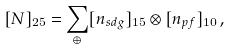Convert formula to latex. <formula><loc_0><loc_0><loc_500><loc_500>[ N ] _ { 2 5 } = \sum _ { \oplus } [ n _ { s d g } ] _ { 1 5 } \otimes [ n _ { p f } ] _ { 1 0 } \, ,</formula> 